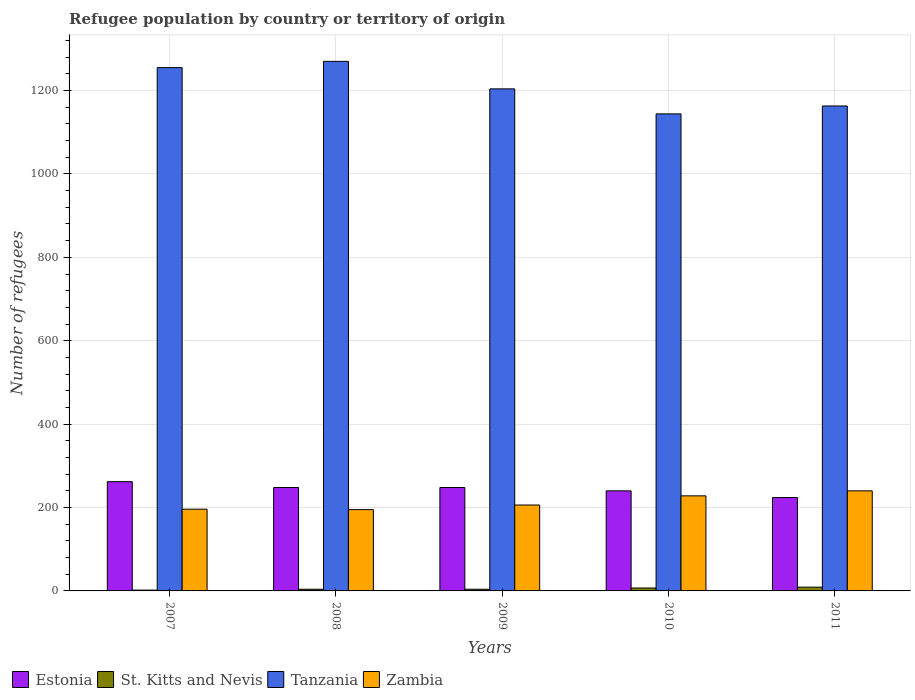How many different coloured bars are there?
Your response must be concise. 4. How many groups of bars are there?
Keep it short and to the point. 5. Are the number of bars per tick equal to the number of legend labels?
Make the answer very short. Yes. How many bars are there on the 3rd tick from the left?
Ensure brevity in your answer.  4. In how many cases, is the number of bars for a given year not equal to the number of legend labels?
Ensure brevity in your answer.  0. Across all years, what is the maximum number of refugees in Zambia?
Ensure brevity in your answer.  240. Across all years, what is the minimum number of refugees in Estonia?
Your answer should be compact. 224. In which year was the number of refugees in St. Kitts and Nevis maximum?
Offer a very short reply. 2011. What is the total number of refugees in St. Kitts and Nevis in the graph?
Your answer should be very brief. 26. What is the difference between the number of refugees in Zambia in 2008 and that in 2010?
Your answer should be very brief. -33. What is the difference between the number of refugees in St. Kitts and Nevis in 2007 and the number of refugees in Estonia in 2009?
Make the answer very short. -246. What is the average number of refugees in Tanzania per year?
Make the answer very short. 1207.2. In the year 2008, what is the difference between the number of refugees in Zambia and number of refugees in Tanzania?
Your answer should be compact. -1075. Is the difference between the number of refugees in Zambia in 2007 and 2009 greater than the difference between the number of refugees in Tanzania in 2007 and 2009?
Ensure brevity in your answer.  No. What is the difference between the highest and the second highest number of refugees in Estonia?
Your answer should be compact. 14. What is the difference between the highest and the lowest number of refugees in Estonia?
Offer a terse response. 38. In how many years, is the number of refugees in Estonia greater than the average number of refugees in Estonia taken over all years?
Offer a terse response. 3. What does the 2nd bar from the left in 2007 represents?
Give a very brief answer. St. Kitts and Nevis. What does the 4th bar from the right in 2009 represents?
Ensure brevity in your answer.  Estonia. Is it the case that in every year, the sum of the number of refugees in Zambia and number of refugees in Tanzania is greater than the number of refugees in Estonia?
Your answer should be very brief. Yes. What is the difference between two consecutive major ticks on the Y-axis?
Offer a terse response. 200. Does the graph contain any zero values?
Offer a very short reply. No. Does the graph contain grids?
Give a very brief answer. Yes. Where does the legend appear in the graph?
Offer a very short reply. Bottom left. How many legend labels are there?
Offer a terse response. 4. How are the legend labels stacked?
Offer a very short reply. Horizontal. What is the title of the graph?
Offer a very short reply. Refugee population by country or territory of origin. Does "Lao PDR" appear as one of the legend labels in the graph?
Ensure brevity in your answer.  No. What is the label or title of the Y-axis?
Offer a very short reply. Number of refugees. What is the Number of refugees in Estonia in 2007?
Your response must be concise. 262. What is the Number of refugees in Tanzania in 2007?
Keep it short and to the point. 1255. What is the Number of refugees in Zambia in 2007?
Ensure brevity in your answer.  196. What is the Number of refugees of Estonia in 2008?
Offer a terse response. 248. What is the Number of refugees of Tanzania in 2008?
Ensure brevity in your answer.  1270. What is the Number of refugees in Zambia in 2008?
Give a very brief answer. 195. What is the Number of refugees of Estonia in 2009?
Provide a short and direct response. 248. What is the Number of refugees in St. Kitts and Nevis in 2009?
Provide a short and direct response. 4. What is the Number of refugees of Tanzania in 2009?
Your answer should be very brief. 1204. What is the Number of refugees in Zambia in 2009?
Keep it short and to the point. 206. What is the Number of refugees in Estonia in 2010?
Your response must be concise. 240. What is the Number of refugees of Tanzania in 2010?
Your answer should be very brief. 1144. What is the Number of refugees in Zambia in 2010?
Your answer should be compact. 228. What is the Number of refugees of Estonia in 2011?
Provide a succinct answer. 224. What is the Number of refugees in Tanzania in 2011?
Keep it short and to the point. 1163. What is the Number of refugees in Zambia in 2011?
Give a very brief answer. 240. Across all years, what is the maximum Number of refugees of Estonia?
Ensure brevity in your answer.  262. Across all years, what is the maximum Number of refugees of St. Kitts and Nevis?
Give a very brief answer. 9. Across all years, what is the maximum Number of refugees of Tanzania?
Offer a very short reply. 1270. Across all years, what is the maximum Number of refugees in Zambia?
Your answer should be very brief. 240. Across all years, what is the minimum Number of refugees in Estonia?
Provide a short and direct response. 224. Across all years, what is the minimum Number of refugees in Tanzania?
Provide a succinct answer. 1144. Across all years, what is the minimum Number of refugees in Zambia?
Make the answer very short. 195. What is the total Number of refugees in Estonia in the graph?
Your answer should be very brief. 1222. What is the total Number of refugees of St. Kitts and Nevis in the graph?
Your response must be concise. 26. What is the total Number of refugees of Tanzania in the graph?
Your answer should be compact. 6036. What is the total Number of refugees in Zambia in the graph?
Offer a terse response. 1065. What is the difference between the Number of refugees in Estonia in 2007 and that in 2008?
Your response must be concise. 14. What is the difference between the Number of refugees in St. Kitts and Nevis in 2007 and that in 2008?
Offer a very short reply. -2. What is the difference between the Number of refugees of Tanzania in 2007 and that in 2008?
Provide a succinct answer. -15. What is the difference between the Number of refugees of Zambia in 2007 and that in 2008?
Provide a short and direct response. 1. What is the difference between the Number of refugees of Estonia in 2007 and that in 2009?
Your answer should be compact. 14. What is the difference between the Number of refugees of Zambia in 2007 and that in 2009?
Offer a terse response. -10. What is the difference between the Number of refugees in Tanzania in 2007 and that in 2010?
Provide a succinct answer. 111. What is the difference between the Number of refugees of Zambia in 2007 and that in 2010?
Provide a succinct answer. -32. What is the difference between the Number of refugees in Tanzania in 2007 and that in 2011?
Offer a terse response. 92. What is the difference between the Number of refugees of Zambia in 2007 and that in 2011?
Your response must be concise. -44. What is the difference between the Number of refugees of Estonia in 2008 and that in 2009?
Keep it short and to the point. 0. What is the difference between the Number of refugees in Estonia in 2008 and that in 2010?
Give a very brief answer. 8. What is the difference between the Number of refugees in St. Kitts and Nevis in 2008 and that in 2010?
Offer a terse response. -3. What is the difference between the Number of refugees of Tanzania in 2008 and that in 2010?
Make the answer very short. 126. What is the difference between the Number of refugees in Zambia in 2008 and that in 2010?
Provide a succinct answer. -33. What is the difference between the Number of refugees in Tanzania in 2008 and that in 2011?
Offer a terse response. 107. What is the difference between the Number of refugees of Zambia in 2008 and that in 2011?
Provide a succinct answer. -45. What is the difference between the Number of refugees of St. Kitts and Nevis in 2009 and that in 2010?
Your response must be concise. -3. What is the difference between the Number of refugees of Tanzania in 2009 and that in 2010?
Offer a terse response. 60. What is the difference between the Number of refugees in Zambia in 2009 and that in 2010?
Your response must be concise. -22. What is the difference between the Number of refugees in Zambia in 2009 and that in 2011?
Offer a very short reply. -34. What is the difference between the Number of refugees of Estonia in 2010 and that in 2011?
Your answer should be very brief. 16. What is the difference between the Number of refugees of St. Kitts and Nevis in 2010 and that in 2011?
Ensure brevity in your answer.  -2. What is the difference between the Number of refugees of Zambia in 2010 and that in 2011?
Your answer should be compact. -12. What is the difference between the Number of refugees of Estonia in 2007 and the Number of refugees of St. Kitts and Nevis in 2008?
Make the answer very short. 258. What is the difference between the Number of refugees in Estonia in 2007 and the Number of refugees in Tanzania in 2008?
Your response must be concise. -1008. What is the difference between the Number of refugees of St. Kitts and Nevis in 2007 and the Number of refugees of Tanzania in 2008?
Provide a short and direct response. -1268. What is the difference between the Number of refugees of St. Kitts and Nevis in 2007 and the Number of refugees of Zambia in 2008?
Offer a terse response. -193. What is the difference between the Number of refugees in Tanzania in 2007 and the Number of refugees in Zambia in 2008?
Give a very brief answer. 1060. What is the difference between the Number of refugees of Estonia in 2007 and the Number of refugees of St. Kitts and Nevis in 2009?
Provide a succinct answer. 258. What is the difference between the Number of refugees in Estonia in 2007 and the Number of refugees in Tanzania in 2009?
Offer a terse response. -942. What is the difference between the Number of refugees of Estonia in 2007 and the Number of refugees of Zambia in 2009?
Your response must be concise. 56. What is the difference between the Number of refugees in St. Kitts and Nevis in 2007 and the Number of refugees in Tanzania in 2009?
Offer a terse response. -1202. What is the difference between the Number of refugees of St. Kitts and Nevis in 2007 and the Number of refugees of Zambia in 2009?
Provide a succinct answer. -204. What is the difference between the Number of refugees of Tanzania in 2007 and the Number of refugees of Zambia in 2009?
Keep it short and to the point. 1049. What is the difference between the Number of refugees of Estonia in 2007 and the Number of refugees of St. Kitts and Nevis in 2010?
Keep it short and to the point. 255. What is the difference between the Number of refugees in Estonia in 2007 and the Number of refugees in Tanzania in 2010?
Give a very brief answer. -882. What is the difference between the Number of refugees of St. Kitts and Nevis in 2007 and the Number of refugees of Tanzania in 2010?
Your answer should be compact. -1142. What is the difference between the Number of refugees of St. Kitts and Nevis in 2007 and the Number of refugees of Zambia in 2010?
Your response must be concise. -226. What is the difference between the Number of refugees of Tanzania in 2007 and the Number of refugees of Zambia in 2010?
Keep it short and to the point. 1027. What is the difference between the Number of refugees in Estonia in 2007 and the Number of refugees in St. Kitts and Nevis in 2011?
Offer a terse response. 253. What is the difference between the Number of refugees in Estonia in 2007 and the Number of refugees in Tanzania in 2011?
Give a very brief answer. -901. What is the difference between the Number of refugees in Estonia in 2007 and the Number of refugees in Zambia in 2011?
Your answer should be very brief. 22. What is the difference between the Number of refugees in St. Kitts and Nevis in 2007 and the Number of refugees in Tanzania in 2011?
Provide a succinct answer. -1161. What is the difference between the Number of refugees in St. Kitts and Nevis in 2007 and the Number of refugees in Zambia in 2011?
Offer a terse response. -238. What is the difference between the Number of refugees of Tanzania in 2007 and the Number of refugees of Zambia in 2011?
Ensure brevity in your answer.  1015. What is the difference between the Number of refugees in Estonia in 2008 and the Number of refugees in St. Kitts and Nevis in 2009?
Provide a short and direct response. 244. What is the difference between the Number of refugees of Estonia in 2008 and the Number of refugees of Tanzania in 2009?
Make the answer very short. -956. What is the difference between the Number of refugees in St. Kitts and Nevis in 2008 and the Number of refugees in Tanzania in 2009?
Give a very brief answer. -1200. What is the difference between the Number of refugees of St. Kitts and Nevis in 2008 and the Number of refugees of Zambia in 2009?
Provide a short and direct response. -202. What is the difference between the Number of refugees in Tanzania in 2008 and the Number of refugees in Zambia in 2009?
Make the answer very short. 1064. What is the difference between the Number of refugees in Estonia in 2008 and the Number of refugees in St. Kitts and Nevis in 2010?
Make the answer very short. 241. What is the difference between the Number of refugees of Estonia in 2008 and the Number of refugees of Tanzania in 2010?
Your answer should be compact. -896. What is the difference between the Number of refugees in St. Kitts and Nevis in 2008 and the Number of refugees in Tanzania in 2010?
Your response must be concise. -1140. What is the difference between the Number of refugees in St. Kitts and Nevis in 2008 and the Number of refugees in Zambia in 2010?
Make the answer very short. -224. What is the difference between the Number of refugees of Tanzania in 2008 and the Number of refugees of Zambia in 2010?
Your answer should be very brief. 1042. What is the difference between the Number of refugees in Estonia in 2008 and the Number of refugees in St. Kitts and Nevis in 2011?
Keep it short and to the point. 239. What is the difference between the Number of refugees of Estonia in 2008 and the Number of refugees of Tanzania in 2011?
Provide a succinct answer. -915. What is the difference between the Number of refugees in St. Kitts and Nevis in 2008 and the Number of refugees in Tanzania in 2011?
Your answer should be compact. -1159. What is the difference between the Number of refugees of St. Kitts and Nevis in 2008 and the Number of refugees of Zambia in 2011?
Your response must be concise. -236. What is the difference between the Number of refugees in Tanzania in 2008 and the Number of refugees in Zambia in 2011?
Your response must be concise. 1030. What is the difference between the Number of refugees of Estonia in 2009 and the Number of refugees of St. Kitts and Nevis in 2010?
Your answer should be compact. 241. What is the difference between the Number of refugees of Estonia in 2009 and the Number of refugees of Tanzania in 2010?
Your response must be concise. -896. What is the difference between the Number of refugees in St. Kitts and Nevis in 2009 and the Number of refugees in Tanzania in 2010?
Offer a very short reply. -1140. What is the difference between the Number of refugees of St. Kitts and Nevis in 2009 and the Number of refugees of Zambia in 2010?
Make the answer very short. -224. What is the difference between the Number of refugees in Tanzania in 2009 and the Number of refugees in Zambia in 2010?
Your response must be concise. 976. What is the difference between the Number of refugees in Estonia in 2009 and the Number of refugees in St. Kitts and Nevis in 2011?
Your response must be concise. 239. What is the difference between the Number of refugees of Estonia in 2009 and the Number of refugees of Tanzania in 2011?
Your response must be concise. -915. What is the difference between the Number of refugees in St. Kitts and Nevis in 2009 and the Number of refugees in Tanzania in 2011?
Give a very brief answer. -1159. What is the difference between the Number of refugees in St. Kitts and Nevis in 2009 and the Number of refugees in Zambia in 2011?
Keep it short and to the point. -236. What is the difference between the Number of refugees of Tanzania in 2009 and the Number of refugees of Zambia in 2011?
Your answer should be compact. 964. What is the difference between the Number of refugees of Estonia in 2010 and the Number of refugees of St. Kitts and Nevis in 2011?
Offer a terse response. 231. What is the difference between the Number of refugees of Estonia in 2010 and the Number of refugees of Tanzania in 2011?
Offer a terse response. -923. What is the difference between the Number of refugees of Estonia in 2010 and the Number of refugees of Zambia in 2011?
Make the answer very short. 0. What is the difference between the Number of refugees of St. Kitts and Nevis in 2010 and the Number of refugees of Tanzania in 2011?
Your answer should be compact. -1156. What is the difference between the Number of refugees in St. Kitts and Nevis in 2010 and the Number of refugees in Zambia in 2011?
Your answer should be very brief. -233. What is the difference between the Number of refugees of Tanzania in 2010 and the Number of refugees of Zambia in 2011?
Offer a terse response. 904. What is the average Number of refugees in Estonia per year?
Offer a terse response. 244.4. What is the average Number of refugees in St. Kitts and Nevis per year?
Your answer should be very brief. 5.2. What is the average Number of refugees in Tanzania per year?
Provide a short and direct response. 1207.2. What is the average Number of refugees in Zambia per year?
Provide a short and direct response. 213. In the year 2007, what is the difference between the Number of refugees in Estonia and Number of refugees in St. Kitts and Nevis?
Give a very brief answer. 260. In the year 2007, what is the difference between the Number of refugees of Estonia and Number of refugees of Tanzania?
Provide a short and direct response. -993. In the year 2007, what is the difference between the Number of refugees of St. Kitts and Nevis and Number of refugees of Tanzania?
Offer a terse response. -1253. In the year 2007, what is the difference between the Number of refugees in St. Kitts and Nevis and Number of refugees in Zambia?
Ensure brevity in your answer.  -194. In the year 2007, what is the difference between the Number of refugees in Tanzania and Number of refugees in Zambia?
Offer a very short reply. 1059. In the year 2008, what is the difference between the Number of refugees of Estonia and Number of refugees of St. Kitts and Nevis?
Keep it short and to the point. 244. In the year 2008, what is the difference between the Number of refugees of Estonia and Number of refugees of Tanzania?
Your response must be concise. -1022. In the year 2008, what is the difference between the Number of refugees in St. Kitts and Nevis and Number of refugees in Tanzania?
Offer a very short reply. -1266. In the year 2008, what is the difference between the Number of refugees in St. Kitts and Nevis and Number of refugees in Zambia?
Your answer should be very brief. -191. In the year 2008, what is the difference between the Number of refugees in Tanzania and Number of refugees in Zambia?
Ensure brevity in your answer.  1075. In the year 2009, what is the difference between the Number of refugees in Estonia and Number of refugees in St. Kitts and Nevis?
Make the answer very short. 244. In the year 2009, what is the difference between the Number of refugees in Estonia and Number of refugees in Tanzania?
Give a very brief answer. -956. In the year 2009, what is the difference between the Number of refugees in Estonia and Number of refugees in Zambia?
Provide a succinct answer. 42. In the year 2009, what is the difference between the Number of refugees in St. Kitts and Nevis and Number of refugees in Tanzania?
Keep it short and to the point. -1200. In the year 2009, what is the difference between the Number of refugees in St. Kitts and Nevis and Number of refugees in Zambia?
Your answer should be very brief. -202. In the year 2009, what is the difference between the Number of refugees of Tanzania and Number of refugees of Zambia?
Offer a terse response. 998. In the year 2010, what is the difference between the Number of refugees of Estonia and Number of refugees of St. Kitts and Nevis?
Offer a terse response. 233. In the year 2010, what is the difference between the Number of refugees of Estonia and Number of refugees of Tanzania?
Provide a short and direct response. -904. In the year 2010, what is the difference between the Number of refugees of St. Kitts and Nevis and Number of refugees of Tanzania?
Give a very brief answer. -1137. In the year 2010, what is the difference between the Number of refugees in St. Kitts and Nevis and Number of refugees in Zambia?
Ensure brevity in your answer.  -221. In the year 2010, what is the difference between the Number of refugees of Tanzania and Number of refugees of Zambia?
Provide a short and direct response. 916. In the year 2011, what is the difference between the Number of refugees in Estonia and Number of refugees in St. Kitts and Nevis?
Provide a short and direct response. 215. In the year 2011, what is the difference between the Number of refugees in Estonia and Number of refugees in Tanzania?
Your response must be concise. -939. In the year 2011, what is the difference between the Number of refugees of St. Kitts and Nevis and Number of refugees of Tanzania?
Give a very brief answer. -1154. In the year 2011, what is the difference between the Number of refugees of St. Kitts and Nevis and Number of refugees of Zambia?
Provide a succinct answer. -231. In the year 2011, what is the difference between the Number of refugees of Tanzania and Number of refugees of Zambia?
Offer a terse response. 923. What is the ratio of the Number of refugees of Estonia in 2007 to that in 2008?
Give a very brief answer. 1.06. What is the ratio of the Number of refugees of St. Kitts and Nevis in 2007 to that in 2008?
Give a very brief answer. 0.5. What is the ratio of the Number of refugees of Tanzania in 2007 to that in 2008?
Your answer should be compact. 0.99. What is the ratio of the Number of refugees in Zambia in 2007 to that in 2008?
Your answer should be very brief. 1.01. What is the ratio of the Number of refugees of Estonia in 2007 to that in 2009?
Your response must be concise. 1.06. What is the ratio of the Number of refugees in Tanzania in 2007 to that in 2009?
Make the answer very short. 1.04. What is the ratio of the Number of refugees of Zambia in 2007 to that in 2009?
Your answer should be very brief. 0.95. What is the ratio of the Number of refugees in Estonia in 2007 to that in 2010?
Offer a very short reply. 1.09. What is the ratio of the Number of refugees of St. Kitts and Nevis in 2007 to that in 2010?
Your answer should be compact. 0.29. What is the ratio of the Number of refugees in Tanzania in 2007 to that in 2010?
Offer a terse response. 1.1. What is the ratio of the Number of refugees in Zambia in 2007 to that in 2010?
Give a very brief answer. 0.86. What is the ratio of the Number of refugees in Estonia in 2007 to that in 2011?
Give a very brief answer. 1.17. What is the ratio of the Number of refugees of St. Kitts and Nevis in 2007 to that in 2011?
Provide a succinct answer. 0.22. What is the ratio of the Number of refugees in Tanzania in 2007 to that in 2011?
Offer a very short reply. 1.08. What is the ratio of the Number of refugees in Zambia in 2007 to that in 2011?
Offer a very short reply. 0.82. What is the ratio of the Number of refugees in Tanzania in 2008 to that in 2009?
Your answer should be very brief. 1.05. What is the ratio of the Number of refugees of Zambia in 2008 to that in 2009?
Your answer should be very brief. 0.95. What is the ratio of the Number of refugees in Estonia in 2008 to that in 2010?
Your answer should be very brief. 1.03. What is the ratio of the Number of refugees of St. Kitts and Nevis in 2008 to that in 2010?
Your response must be concise. 0.57. What is the ratio of the Number of refugees of Tanzania in 2008 to that in 2010?
Provide a short and direct response. 1.11. What is the ratio of the Number of refugees of Zambia in 2008 to that in 2010?
Keep it short and to the point. 0.86. What is the ratio of the Number of refugees in Estonia in 2008 to that in 2011?
Your response must be concise. 1.11. What is the ratio of the Number of refugees in St. Kitts and Nevis in 2008 to that in 2011?
Your answer should be compact. 0.44. What is the ratio of the Number of refugees of Tanzania in 2008 to that in 2011?
Provide a short and direct response. 1.09. What is the ratio of the Number of refugees of Zambia in 2008 to that in 2011?
Offer a very short reply. 0.81. What is the ratio of the Number of refugees in St. Kitts and Nevis in 2009 to that in 2010?
Offer a terse response. 0.57. What is the ratio of the Number of refugees of Tanzania in 2009 to that in 2010?
Offer a very short reply. 1.05. What is the ratio of the Number of refugees in Zambia in 2009 to that in 2010?
Your answer should be compact. 0.9. What is the ratio of the Number of refugees of Estonia in 2009 to that in 2011?
Offer a terse response. 1.11. What is the ratio of the Number of refugees in St. Kitts and Nevis in 2009 to that in 2011?
Offer a terse response. 0.44. What is the ratio of the Number of refugees in Tanzania in 2009 to that in 2011?
Your answer should be compact. 1.04. What is the ratio of the Number of refugees of Zambia in 2009 to that in 2011?
Your answer should be compact. 0.86. What is the ratio of the Number of refugees of Estonia in 2010 to that in 2011?
Offer a very short reply. 1.07. What is the ratio of the Number of refugees in Tanzania in 2010 to that in 2011?
Your answer should be compact. 0.98. What is the difference between the highest and the second highest Number of refugees in Estonia?
Provide a succinct answer. 14. What is the difference between the highest and the second highest Number of refugees in Tanzania?
Ensure brevity in your answer.  15. What is the difference between the highest and the second highest Number of refugees in Zambia?
Give a very brief answer. 12. What is the difference between the highest and the lowest Number of refugees in Estonia?
Make the answer very short. 38. What is the difference between the highest and the lowest Number of refugees in St. Kitts and Nevis?
Offer a very short reply. 7. What is the difference between the highest and the lowest Number of refugees of Tanzania?
Make the answer very short. 126. What is the difference between the highest and the lowest Number of refugees of Zambia?
Your answer should be compact. 45. 